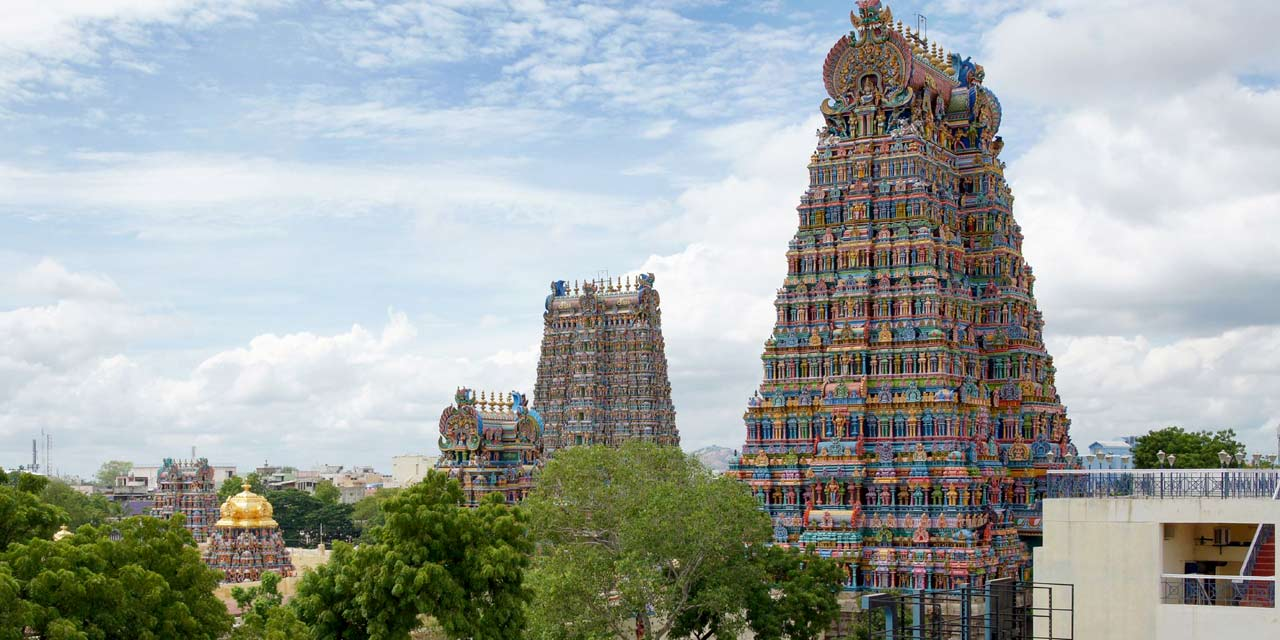Can you elaborate on the elements of the picture provided? The image captures the stunning Meenakshi Amman Temple situated in Madurai, India. Dominating the scene are the temple's towering gopurams (gateway towers), rich in intricate sculptures depicting various deities and mythological creatures. These ornate towers are adorned with a plethora of vibrant colors such as blue, green, red, yellow, and more, creating a visual feast. Surrounding the temple are lush green trees and plants, further enhancing the vividness of the scene. Above, the sky is a serene canvas painted in light blue hues with scattered fluffy white clouds. The distant perspective of the image allows us to appreciate the grand scale and intricate detailing of the temple, showcasing its architectural magnificence alongside the harmonious integration with the natural and urban environment around it. This remarkable temple stands as a testament to the artistic and architectural achievements of its creators. 